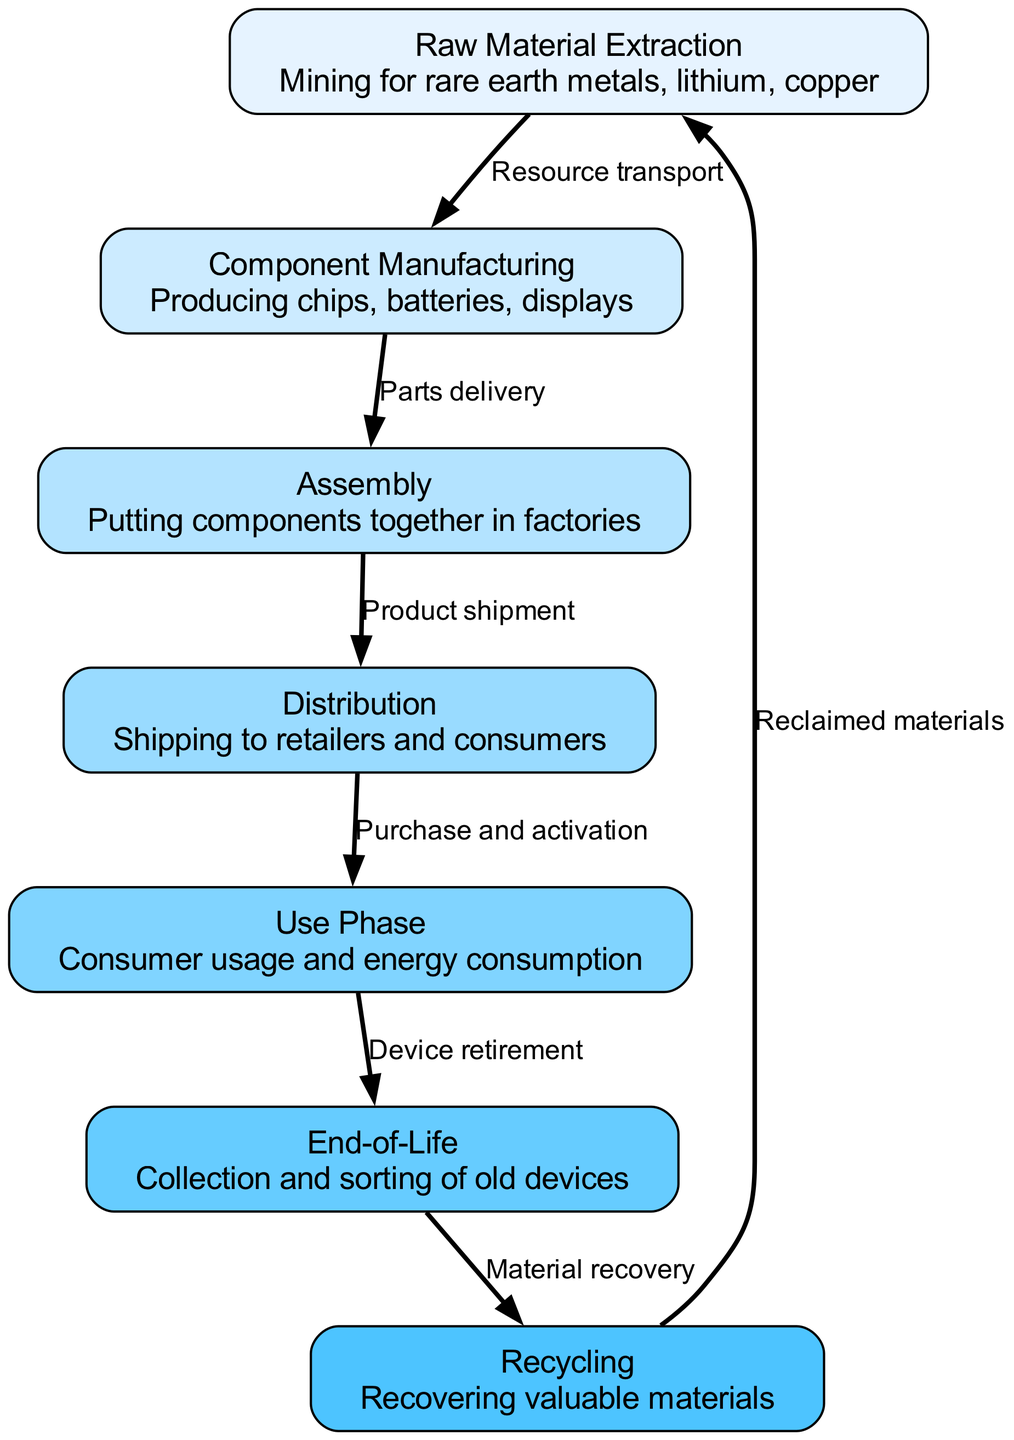What is the first step in the smartphone lifecycle? The first step is represented by the node "Raw Material Extraction," which includes mining for materials like rare earth metals, lithium, and copper.
Answer: Raw Material Extraction How many nodes are present in the diagram? By counting the nodes listed, there are a total of seven nodes representing different stages of the smartphone lifecycle.
Answer: 7 What connects "Component Manufacturing" to "Assembly"? The connection between these two nodes is labeled "Parts delivery," indicating the flow of parts required for assembly.
Answer: Parts delivery What is the final stage before recycling in the smartphone lifecycle? The final stage before recycling is "End-of-Life," which encompasses the collection and sorting of old devices.
Answer: End-of-Life How does the lifecycle of a smartphone begin and end? The lifecycle begins with "Raw Material Extraction" and ends with "Recycling," which recovers valuable materials that can be used again, forming a loop back to raw material extraction.
Answer: Raw Material Extraction and Recycling What stage involves consumer usage? The stage where consumer usage occurs is labeled "Use Phase," emphasizing the period during which consumers actively use the smartphone and its energy consumption.
Answer: Use Phase What is the relationship between "Use Phase" and "End-of-Life"? The relationship between these two nodes is indicated by the label "Device retirement," showing the transition from active use to the stage where devices are retired.
Answer: Device retirement Which node focuses on environmental recovery processes? The node specifically addressing environmental recovery processes is "Recycling," where valuable materials are recovered from old devices.
Answer: Recycling What transportation process occurs after raw materials are extracted? After raw materials are extracted, the first transportation process is labeled "Resource transport," which indicates how these materials are moved to the next stage of manufacturing.
Answer: Resource transport 